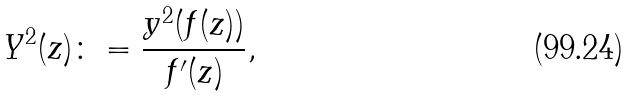<formula> <loc_0><loc_0><loc_500><loc_500>Y ^ { 2 } ( z ) \colon = \frac { y ^ { 2 } ( f ( z ) ) } { f ^ { \prime } ( z ) } ,</formula> 